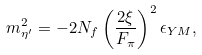<formula> <loc_0><loc_0><loc_500><loc_500>m _ { \eta ^ { \prime } } ^ { 2 } = - 2 N _ { f } \left ( { \frac { 2 \xi } { F _ { \pi } } } \right ) ^ { 2 } \epsilon _ { Y M } ,</formula> 